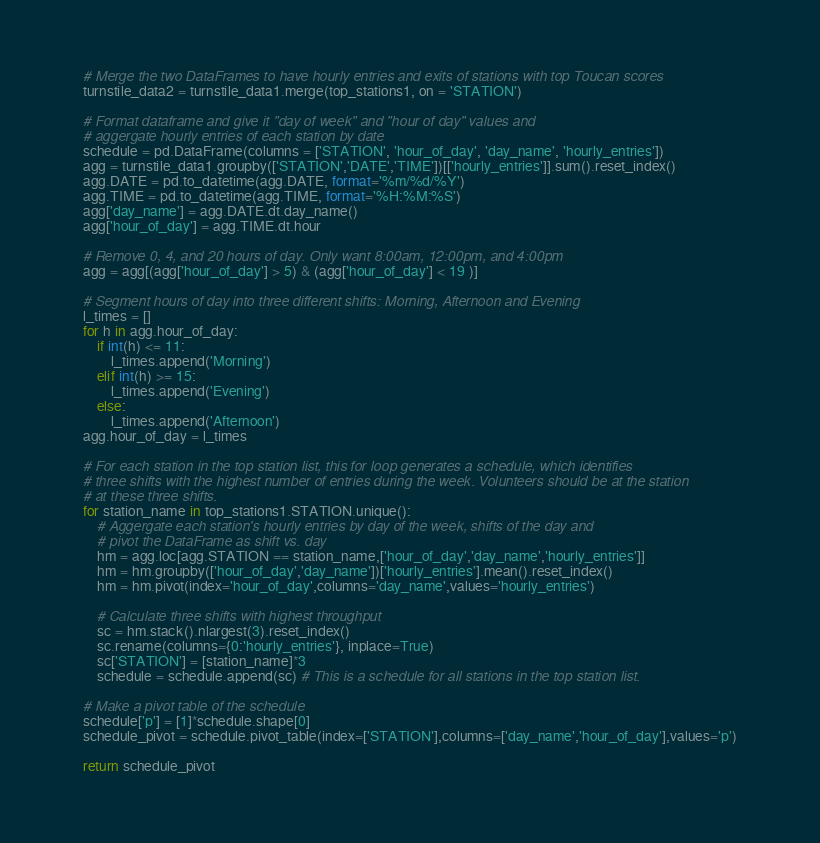Convert code to text. <code><loc_0><loc_0><loc_500><loc_500><_Python_>    # Merge the two DataFrames to have hourly entries and exits of stations with top Toucan scores
    turnstile_data2 = turnstile_data1.merge(top_stations1, on = 'STATION')
    
    # Format dataframe and give it "day of week" and "hour of day" values and
    # aggergate hourly entries of each station by date
    schedule = pd.DataFrame(columns = ['STATION', 'hour_of_day', 'day_name', 'hourly_entries'])
    agg = turnstile_data1.groupby(['STATION','DATE','TIME'])[['hourly_entries']].sum().reset_index()
    agg.DATE = pd.to_datetime(agg.DATE, format='%m/%d/%Y')
    agg.TIME = pd.to_datetime(agg.TIME, format='%H:%M:%S')
    agg['day_name'] = agg.DATE.dt.day_name()
    agg['hour_of_day'] = agg.TIME.dt.hour
    
    # Remove 0, 4, and 20 hours of day. Only want 8:00am, 12:00pm, and 4:00pm
    agg = agg[(agg['hour_of_day'] > 5) & (agg['hour_of_day'] < 19 )]
    
    # Segment hours of day into three different shifts: Morning, Afternoon and Evening
    l_times = []
    for h in agg.hour_of_day:
        if int(h) <= 11:
            l_times.append('Morning')
        elif int(h) >= 15:
            l_times.append('Evening')
        else:
            l_times.append('Afternoon')
    agg.hour_of_day = l_times
    
    # For each station in the top station list, this for loop generates a schedule, which identifies 
    # three shifts with the highest number of entries during the week. Volunteers should be at the station
    # at these three shifts.
    for station_name in top_stations1.STATION.unique():
        # Aggergate each station's hourly entries by day of the week, shifts of the day and 
        # pivot the DataFrame as shift vs. day
        hm = agg.loc[agg.STATION == station_name,['hour_of_day','day_name','hourly_entries']]
        hm = hm.groupby(['hour_of_day','day_name'])['hourly_entries'].mean().reset_index()
        hm = hm.pivot(index='hour_of_day',columns='day_name',values='hourly_entries')

        # Calculate three shifts with highest throughput
        sc = hm.stack().nlargest(3).reset_index() 
        sc.rename(columns={0:'hourly_entries'}, inplace=True)
        sc['STATION'] = [station_name]*3
        schedule = schedule.append(sc) # This is a schedule for all stations in the top station list.

    # Make a pivot table of the schedule
    schedule['p'] = [1]*schedule.shape[0]
    schedule_pivot = schedule.pivot_table(index=['STATION'],columns=['day_name','hour_of_day'],values='p')    
    
    return schedule_pivot</code> 